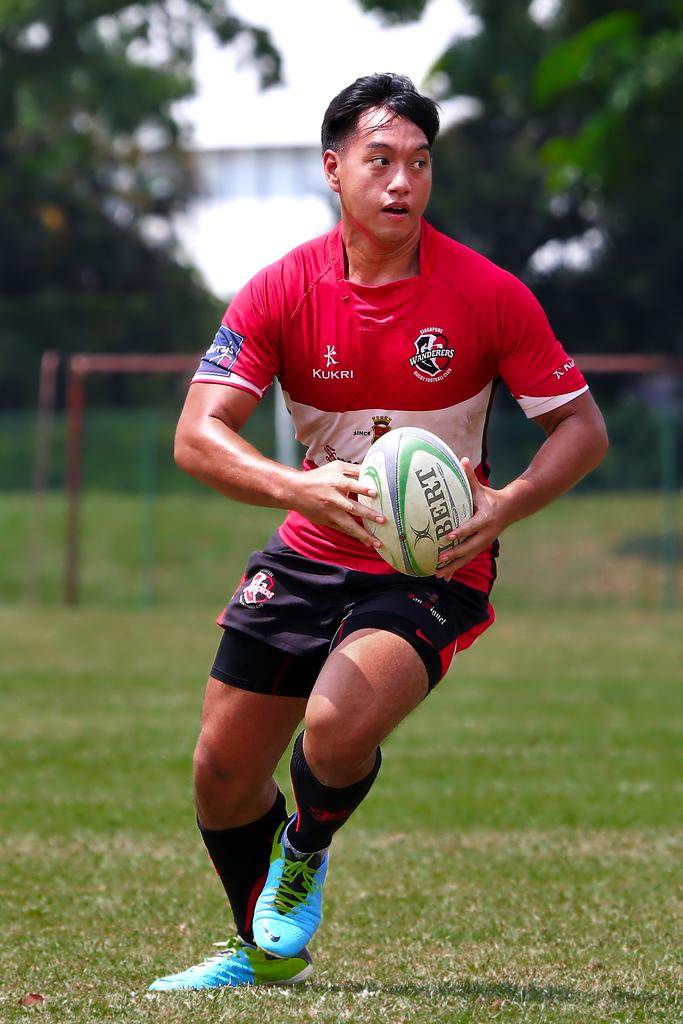Who is the main subject in the image? There is a person in the center of the image. What is the person holding in the image? The person is holding a ball. What is the person's posture in the image? The person is standing. What can be seen in the background of the image? There is a net and trees in the background of the image, as well as the sky. What type of stew is being served at the person's aunt's house in the image? There is no mention of stew, a person's aunt, or any food in the image. 